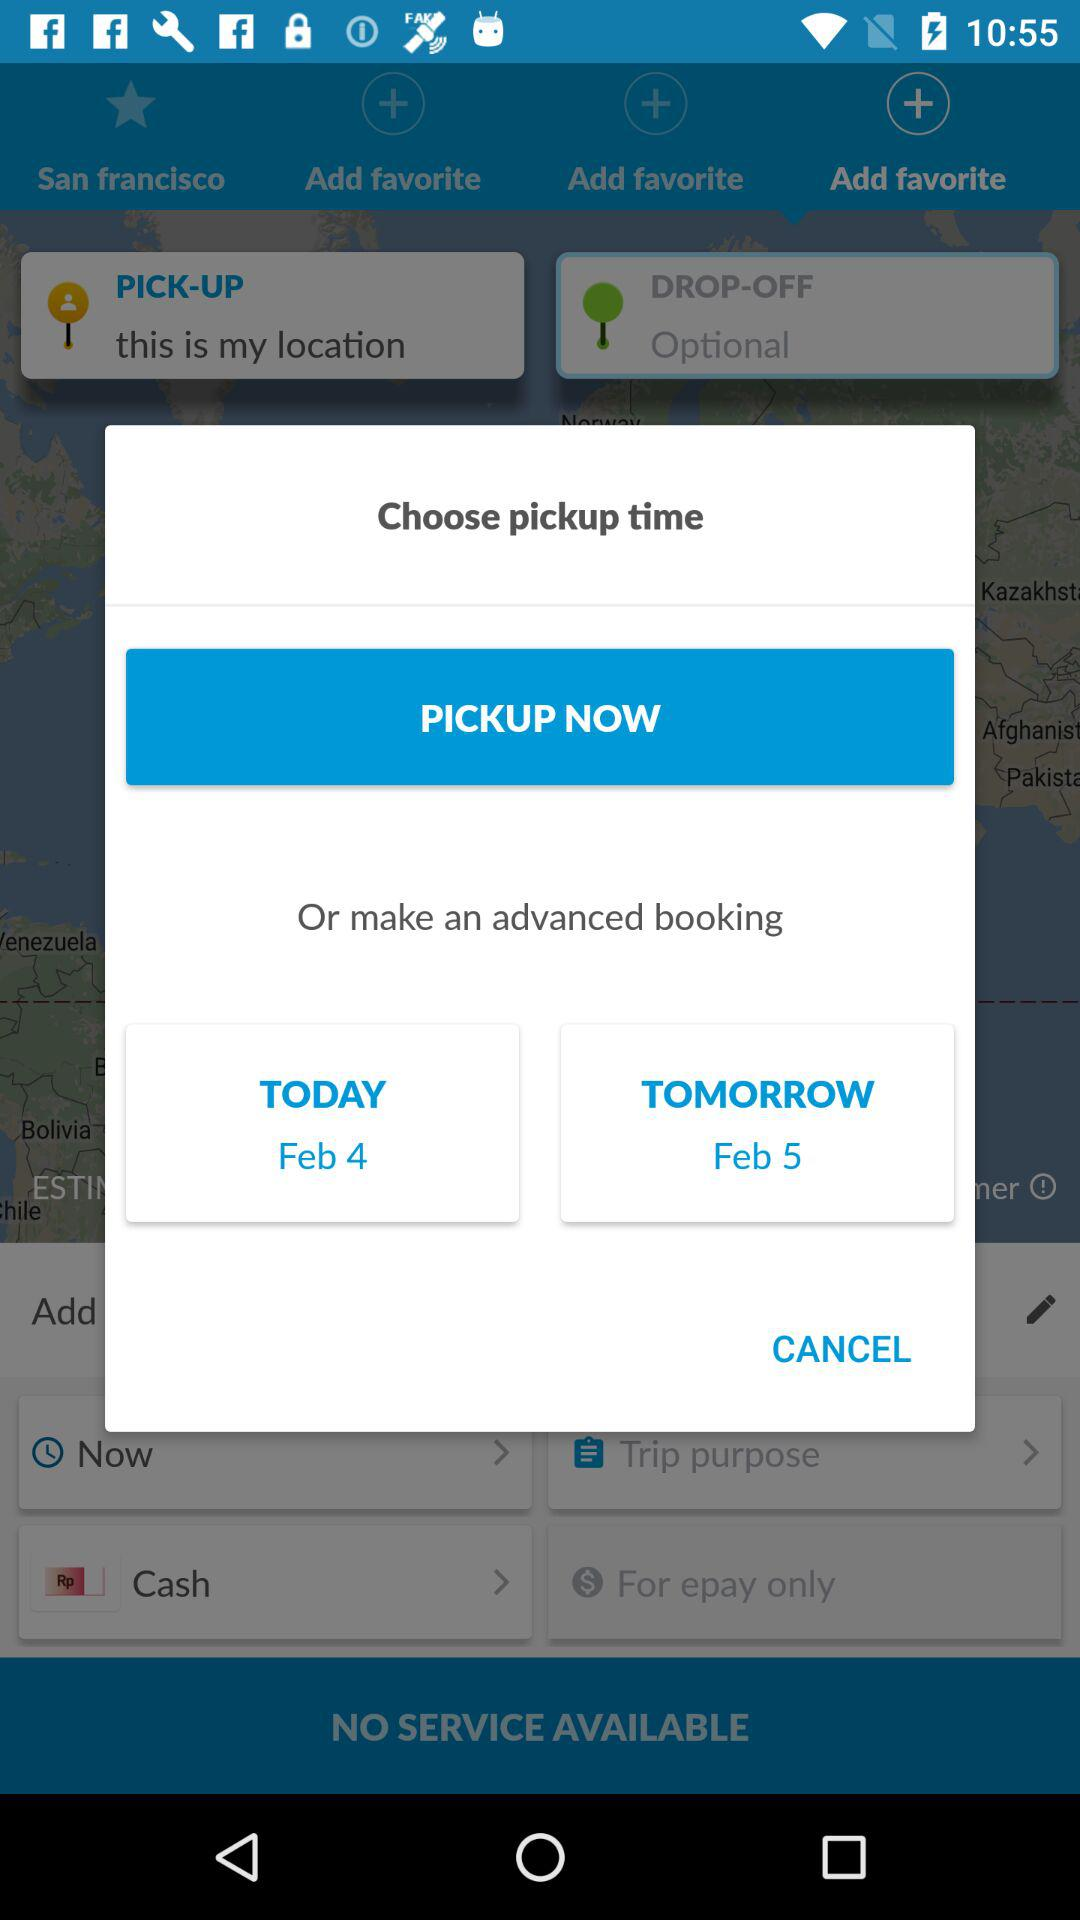What is today's shown date? Today's shown date is February 4. 